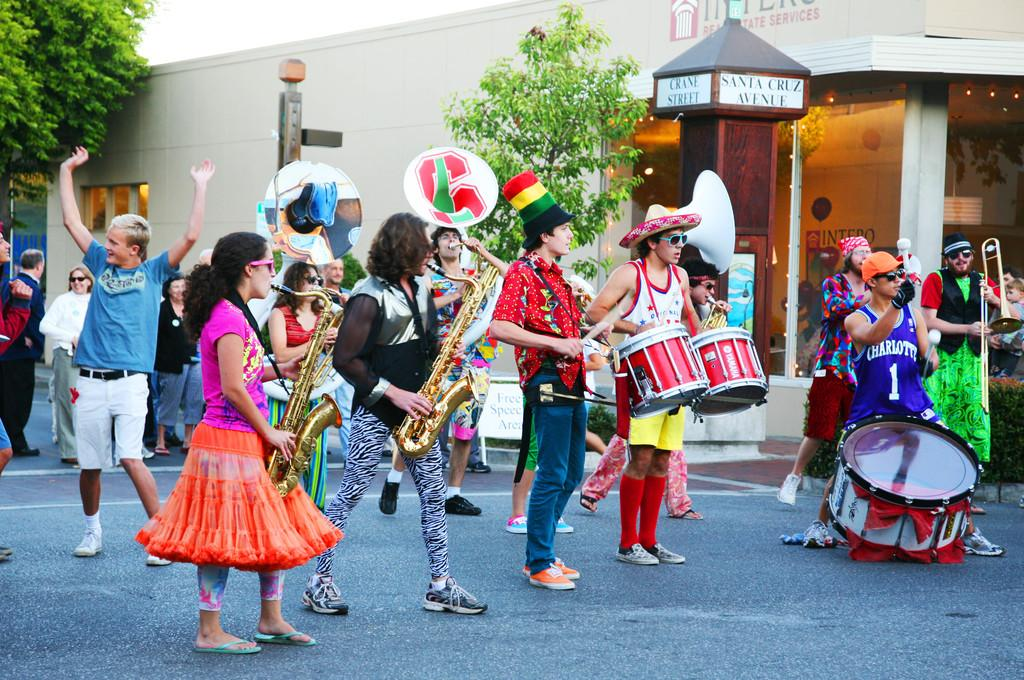What is happening in the center of the image? There is a group of persons in the center of the image. What are the persons doing in the image? The persons are holding musical instruments and performing. Where are they performing? They are performing on the road. What can be seen in the background of the image? There is a building, trees, windows, and the sky visible in the background of the image. What is the purpose of the furniture in the image? There is no furniture present in the image. 